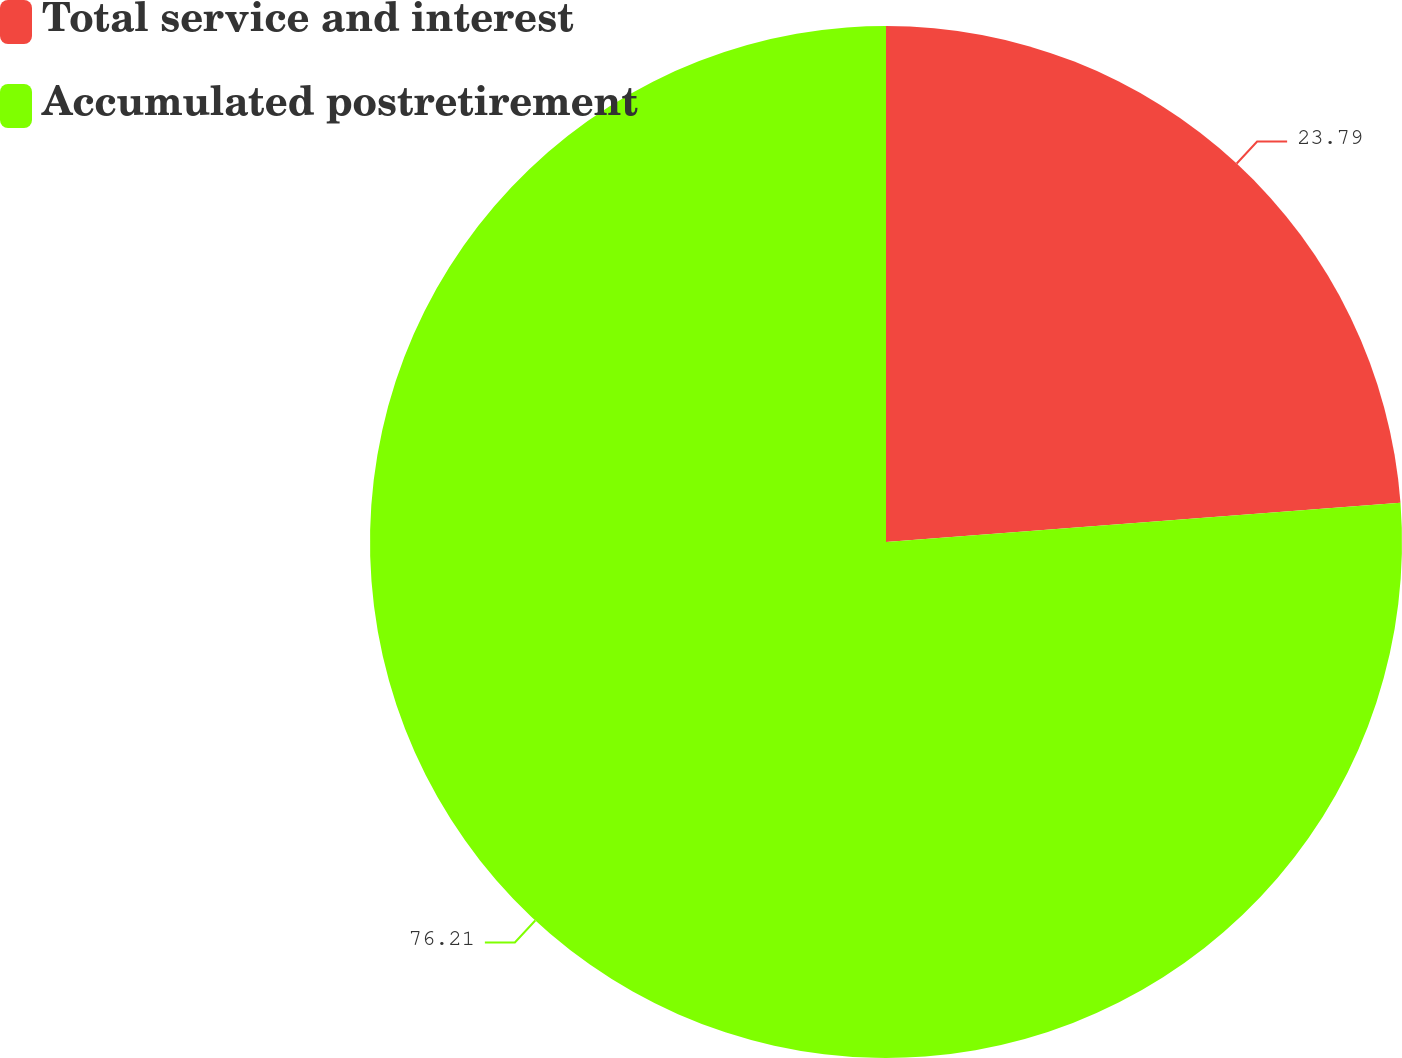Convert chart. <chart><loc_0><loc_0><loc_500><loc_500><pie_chart><fcel>Total service and interest<fcel>Accumulated postretirement<nl><fcel>23.79%<fcel>76.21%<nl></chart> 